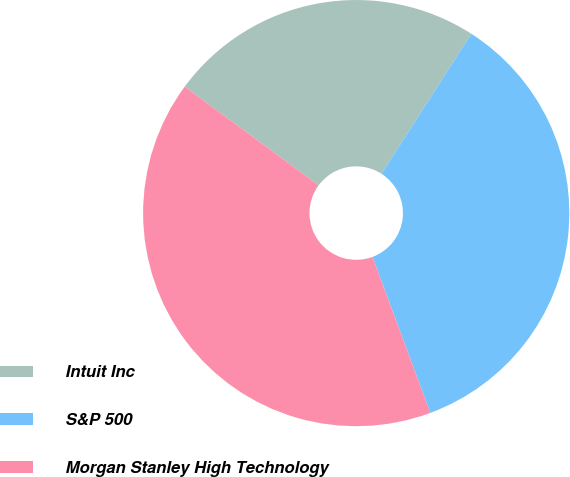Convert chart to OTSL. <chart><loc_0><loc_0><loc_500><loc_500><pie_chart><fcel>Intuit Inc<fcel>S&P 500<fcel>Morgan Stanley High Technology<nl><fcel>23.97%<fcel>35.26%<fcel>40.77%<nl></chart> 